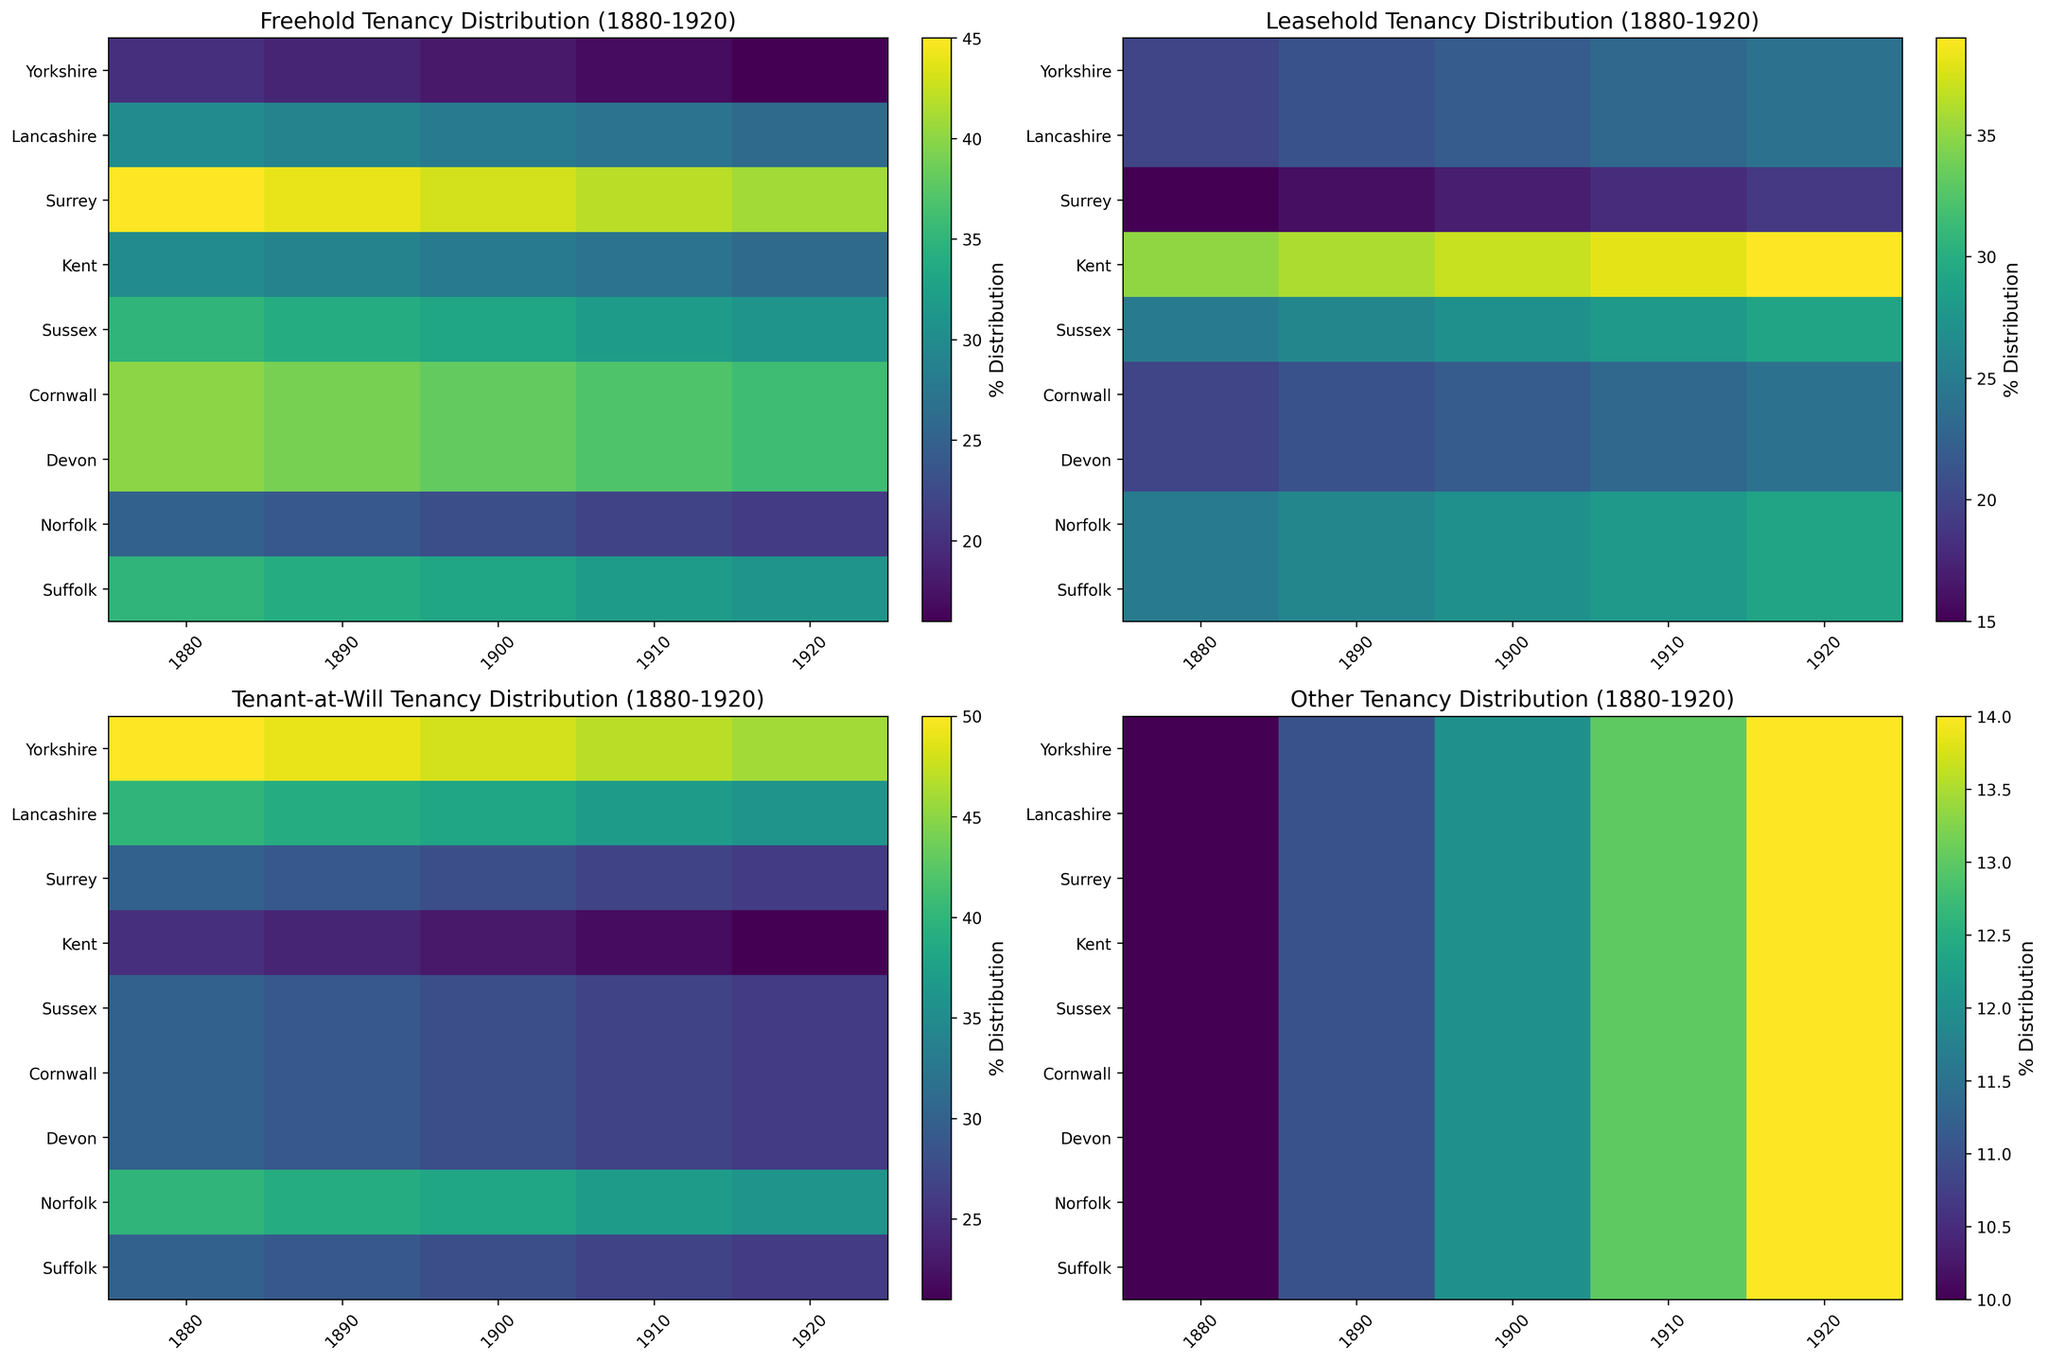What is the average percentage of Freehold tenancy in Yorkshire over the years? To find the average percentage of Freehold tenancy in Yorkshire, sum the values for each year and divide by the number of years: (35 + 34 + 33 + 32 + 31) / 5 = 165 / 5 = 33
Answer: 33 In 1920, which county had the highest percentage of Leasehold tenancy? Look at the Leasehold heatmap for the year 1920, and identify the county with the highest value. The value for Lancashire is highest at 39.
Answer: Lancashire Did the percentage of Tenant-at-Will tenancy in Sussex increase or decrease from 1880 to 1920? Compare the values in Sussex for the years 1880 and 1920. The value decreases from 40 to 36.
Answer: Decrease Which county shows the most significant increase in 'Other' tenancy from 1880 to 1920? Calculate the difference in 'Other' tenancy for each county from 1880 to 1920. The differences are: Yorkshire: 4, Lancashire: 4, Surrey: 4, Kent: 4, Sussex: 4, Cornwall: 4, Devon: 4, Norfolk: 4, Suffolk: 4. All counties show the same increase.
Answer: All counties What is the total percentage of Leasehold tenancy across all counties in 1900? Sum the Leasehold values for all counties in 1900: 27 + 37 + 22 + 17 + 27 + 22 + 22 + 27 + 22 = 221
Answer: 221 Which year shows the lowest percentage of Freehold tenancy in Devon? Look at the Freehold values for Devon across all years and identify the lowest value. The lowest value is 26 in 1920.
Answer: 1920 Is the percentage of 'Other' tenancy generally increasing or decreasing across all counties from 1880 to 1920? Observe the trend of 'Other' values for all counties over the years. The values generally increase from 10 to 14.
Answer: Increasing Compare the percentage change in Leasehold tenancy between 1880 and 1920 for Yorkshire and Cornwall. Which county had a more significant change? Calculate the change for both counties. Yorkshire: 29 - 25 = 4; Cornwall: 24 - 20 = 4. Both counties have the same change of 4.
Answer: Both have the same change What is the percentage range of Tenant-at-Will tenancy in Sussex from 1880 to 1920? Identify the minimum and maximum Tenant-at-Will values in Sussex over the years. Min: 36, Max: 40, so the range is 40 - 36 = 4
Answer: 4 Between Yorkshire and Lancashire, which county had a higher average Freehold tenancy percentage over 40 years? Calculate the average for both counties: Yorkshire: (35 + 34 + 33 + 32 + 31) / 5 = 33, Lancashire: (30 + 29 + 28 + 27 + 26) / 5 = 28
Answer: Yorkshire 